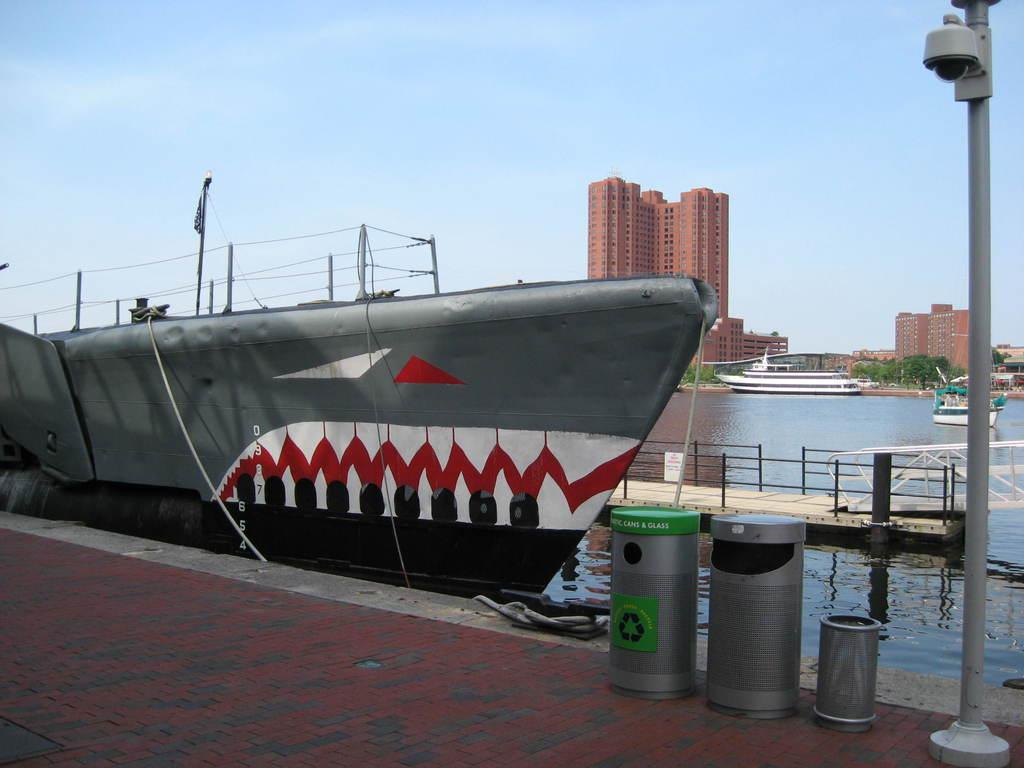Provide a one-sentence caption for the provided image. A submarine with a shark face painted on it is docked next to a Can and Glass recycling bin and two trash cans. 